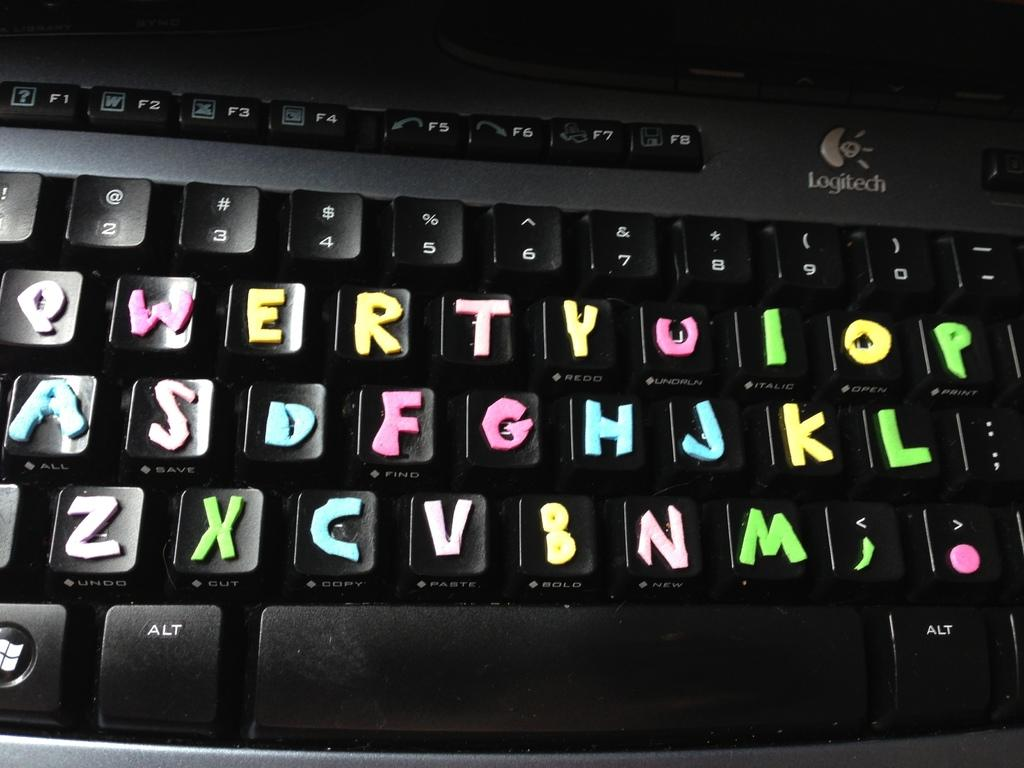What is the main object in the image? There is a keyboard in the image. What might the keyboard be used for? The keyboard is likely used for typing or playing music, depending on the context. Can you describe the appearance of the keyboard? The image only shows the keyboard, so it's difficult to provide a detailed description of its appearance. What class is being taught in the image? There is no class or teaching activity depicted in the image; it only shows a keyboard. How does the wind affect the keyboard in the image? There is no wind present in the image, and the keyboard is not affected by any external factors. 